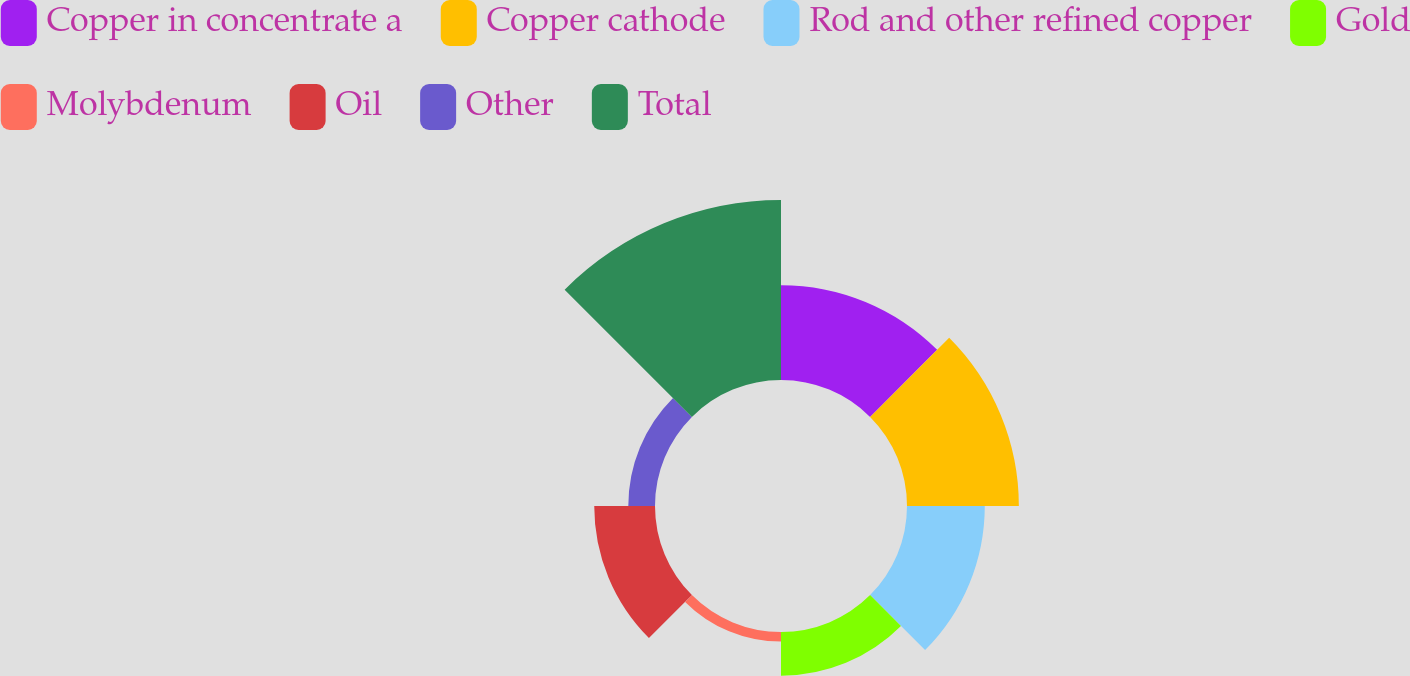Convert chart. <chart><loc_0><loc_0><loc_500><loc_500><pie_chart><fcel>Copper in concentrate a<fcel>Copper cathode<fcel>Rod and other refined copper<fcel>Gold<fcel>Molybdenum<fcel>Oil<fcel>Other<fcel>Total<nl><fcel>15.67%<fcel>18.48%<fcel>12.85%<fcel>7.22%<fcel>1.59%<fcel>10.04%<fcel>4.41%<fcel>29.74%<nl></chart> 